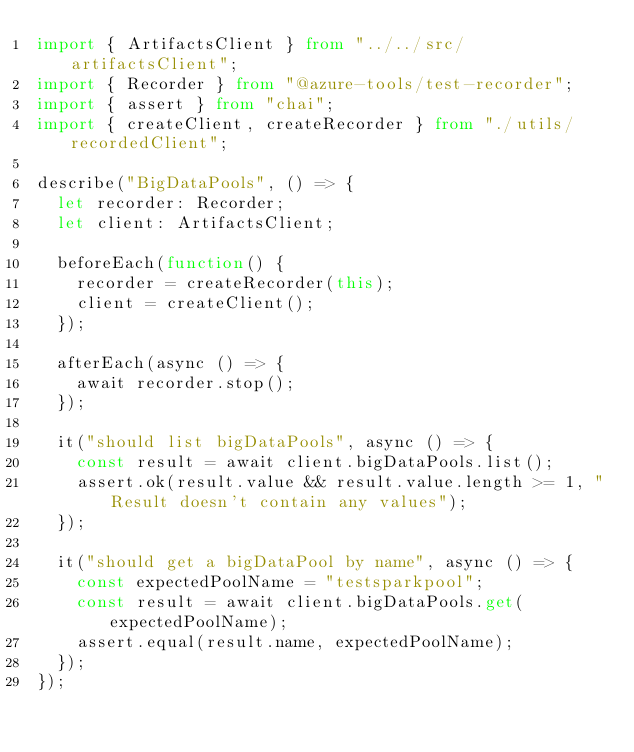Convert code to text. <code><loc_0><loc_0><loc_500><loc_500><_TypeScript_>import { ArtifactsClient } from "../../src/artifactsClient";
import { Recorder } from "@azure-tools/test-recorder";
import { assert } from "chai";
import { createClient, createRecorder } from "./utils/recordedClient";

describe("BigDataPools", () => {
  let recorder: Recorder;
  let client: ArtifactsClient;

  beforeEach(function() {
    recorder = createRecorder(this);
    client = createClient();
  });

  afterEach(async () => {
    await recorder.stop();
  });

  it("should list bigDataPools", async () => {
    const result = await client.bigDataPools.list();
    assert.ok(result.value && result.value.length >= 1, "Result doesn't contain any values");
  });

  it("should get a bigDataPool by name", async () => {
    const expectedPoolName = "testsparkpool";
    const result = await client.bigDataPools.get(expectedPoolName);
    assert.equal(result.name, expectedPoolName);
  });
});
</code> 